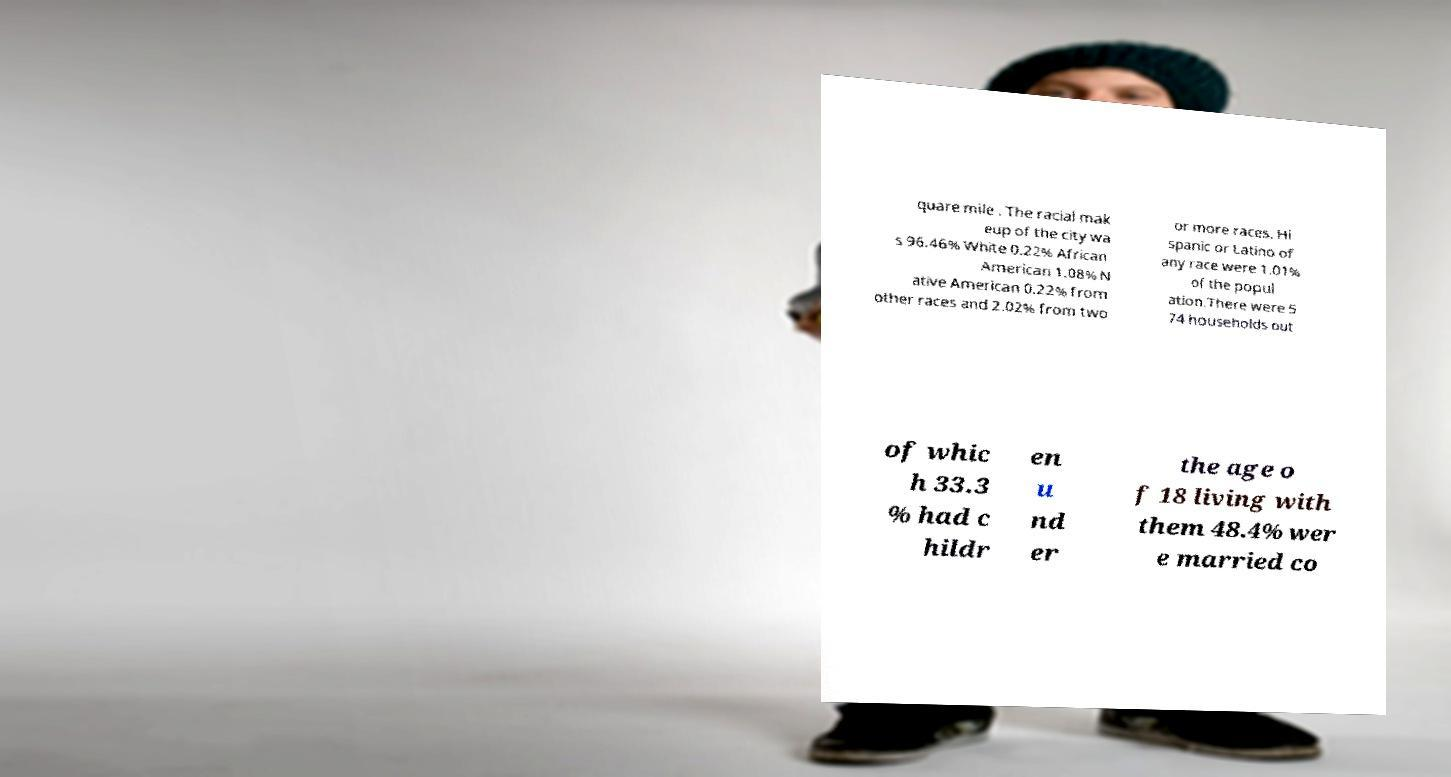Please identify and transcribe the text found in this image. quare mile . The racial mak eup of the city wa s 96.46% White 0.22% African American 1.08% N ative American 0.22% from other races and 2.02% from two or more races. Hi spanic or Latino of any race were 1.01% of the popul ation.There were 5 74 households out of whic h 33.3 % had c hildr en u nd er the age o f 18 living with them 48.4% wer e married co 